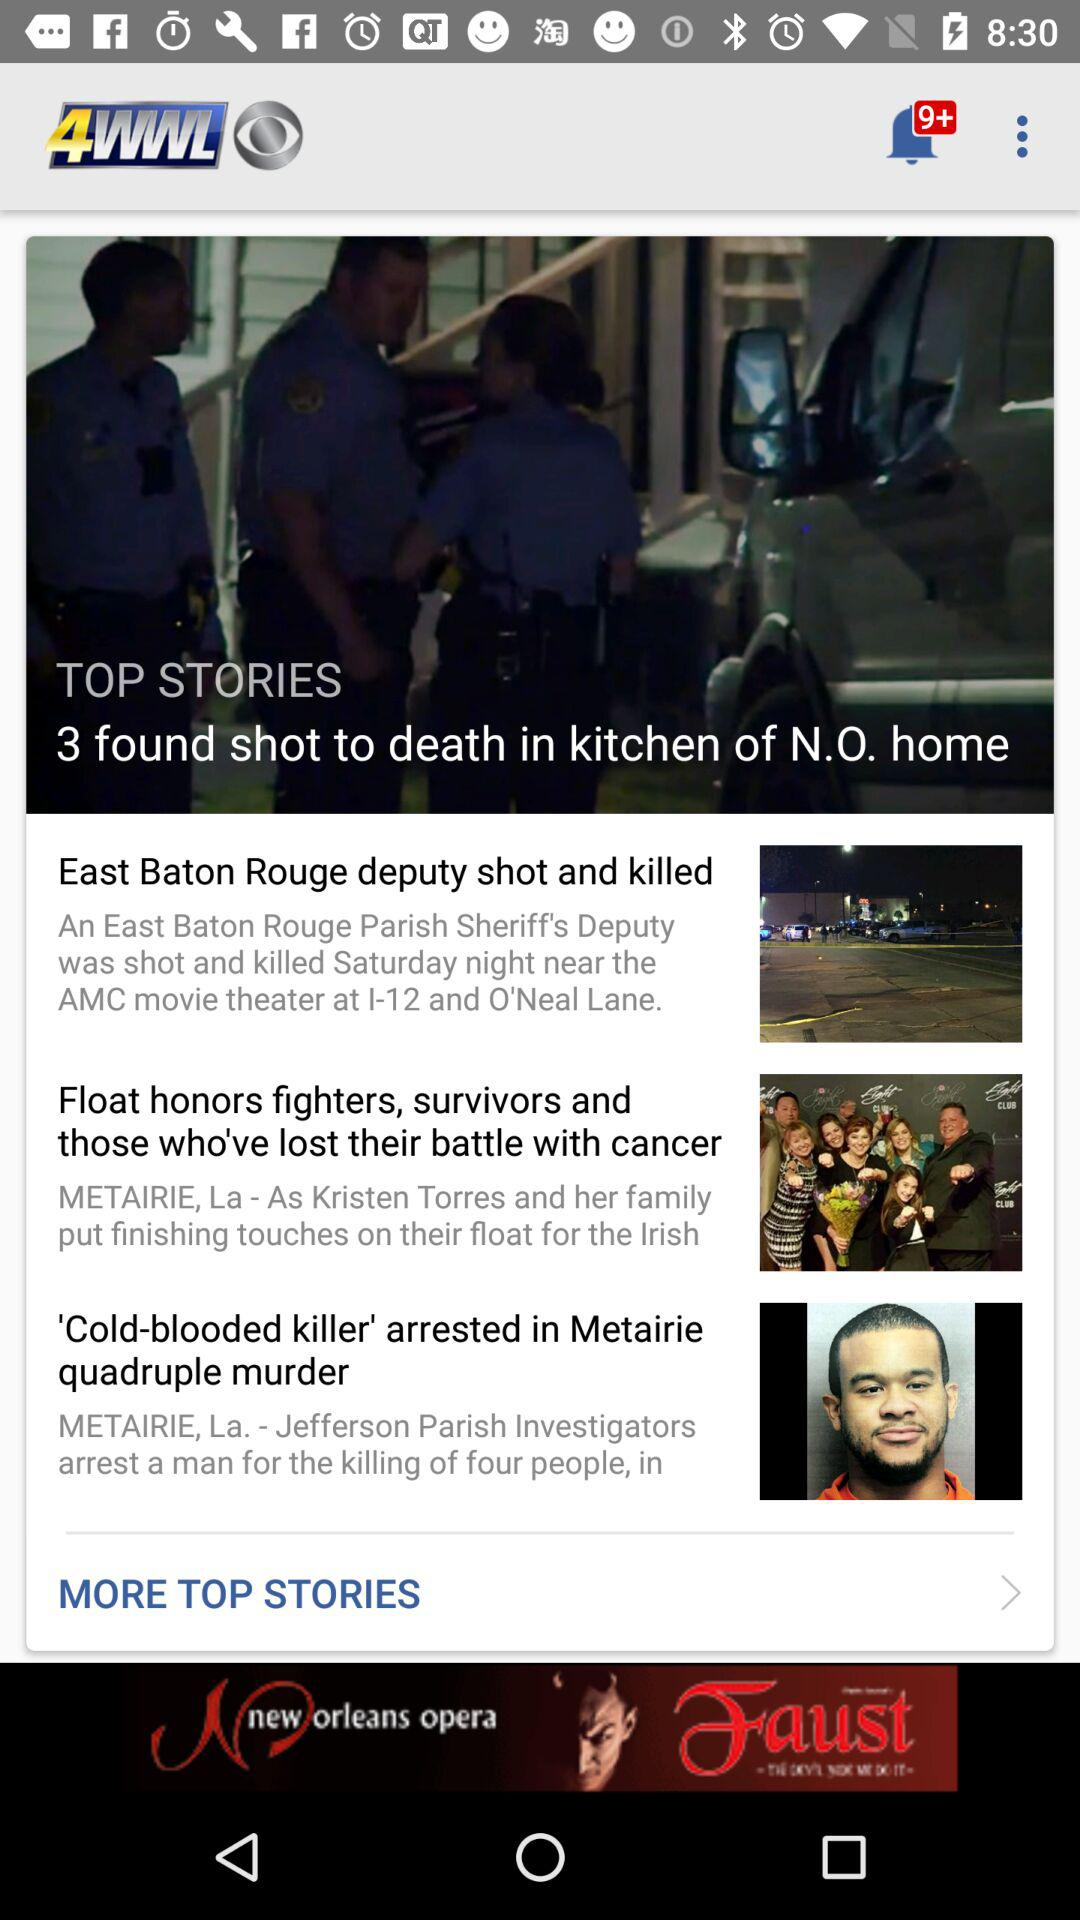How many new notifications are there? There are 9+ notifications. 